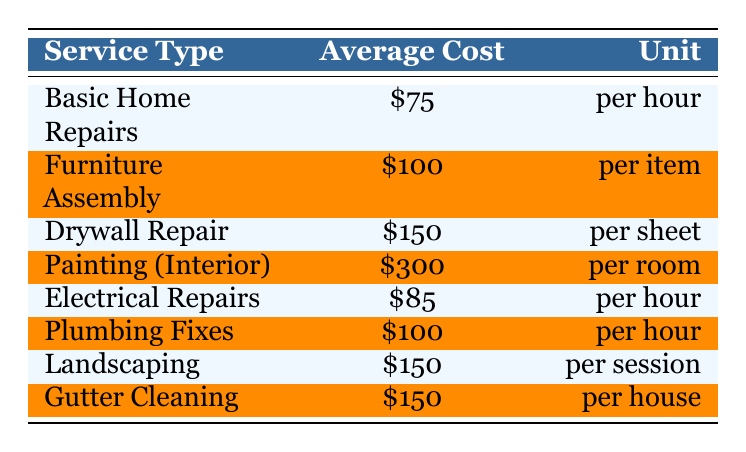What is the average cost for Basic Home Repairs? The table shows that the average cost for Basic Home Repairs is listed as 75, which is the value in the "Average Cost" column for this service type.
Answer: 75 How much does it cost to assemble one piece of furniture? According to the table, the average cost for Furniture Assembly is 100, as found in the corresponding row for this service type.
Answer: 100 Are Electrical Repairs more expensive than Plumbing Fixes? The table lists Electrical Repairs at 85 and Plumbing Fixes at 100. Since 85 is less than 100, the statement is false.
Answer: No What is the total average cost of hiring a handyman for both Basic Home Repairs and Electrical Repairs for two hours? For Basic Home Repairs, the cost is 75 per hour, so for two hours it would be 75 * 2 = 150. For Electrical Repairs, at 85 per hour, the two-hour cost is 85 * 2 = 170. Adding these two results together gives 150 + 170 = 320.
Answer: 320 Which handyman service has the highest average cost per session or per unit? By examining the average cost values in the table, Painting (Interior) at 300 is the highest cost listed. Other services have lower costs, confirming that Painting has the highest average cost.
Answer: Painting (Interior) What is the average cost for a session of Landscaping? The average cost for Landscaping is directly provided in the table as 150.
Answer: 150 Is the average cost for Gutter Cleaning less than the cost of Drywall Repair? The average cost for Gutter Cleaning is listed as 150, while Drywall Repair is listed at 150 as well. Since both costs are the same, the statement is false.
Answer: No If I need to paint two rooms, how much would that cost? According to the table, the average cost for Painting (Interior) is 300 per room. For two rooms, the total cost would be 300 * 2 = 600.
Answer: 600 